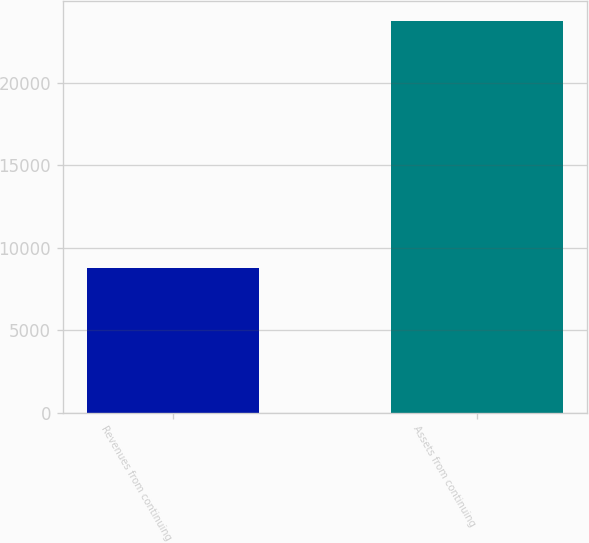<chart> <loc_0><loc_0><loc_500><loc_500><bar_chart><fcel>Revenues from continuing<fcel>Assets from continuing<nl><fcel>8776.5<fcel>23734.4<nl></chart> 